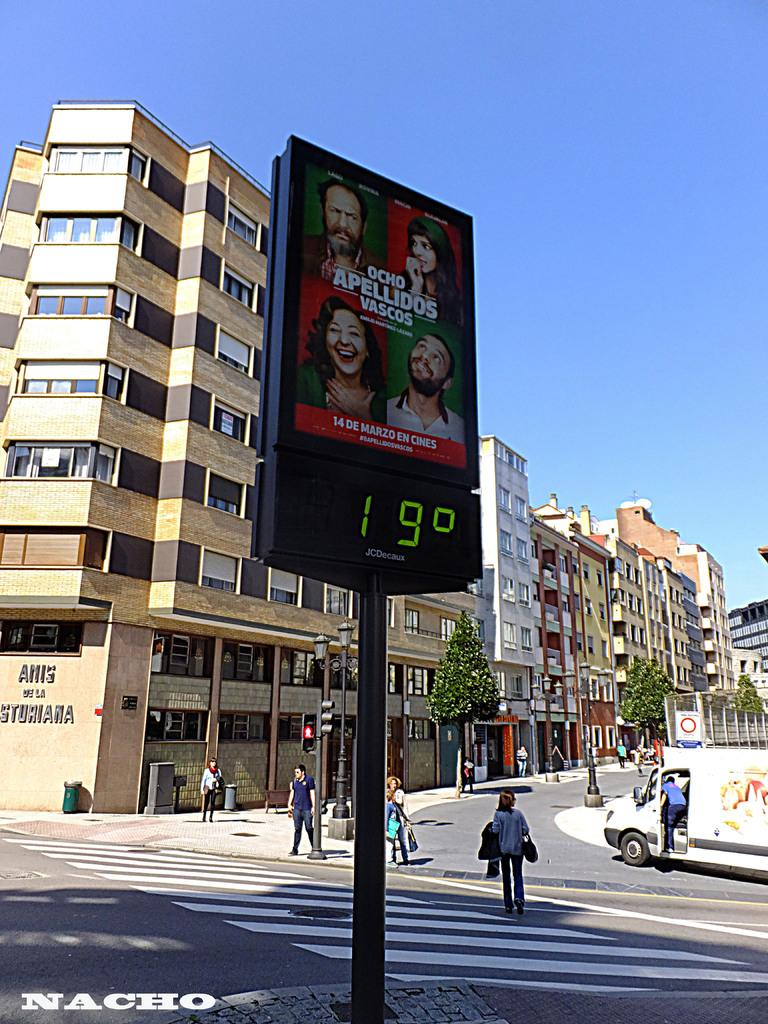<image>
Provide a brief description of the given image. A sign that says 19 degrees on it with writing on it 